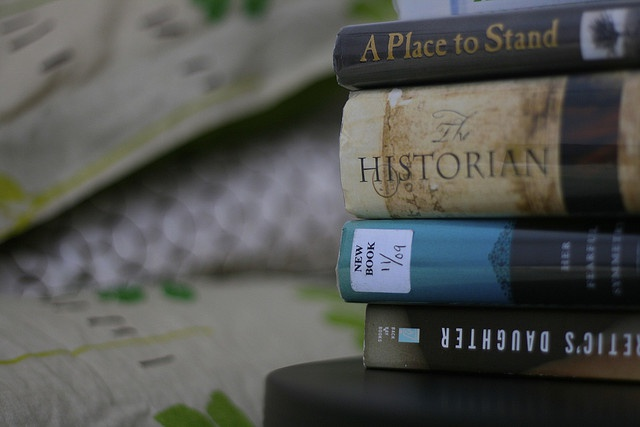Describe the objects in this image and their specific colors. I can see bed in gray, black, and darkgreen tones, book in gray, black, and darkgray tones, book in gray, black, blue, navy, and darkgray tones, book in gray and black tones, and book in gray and black tones in this image. 